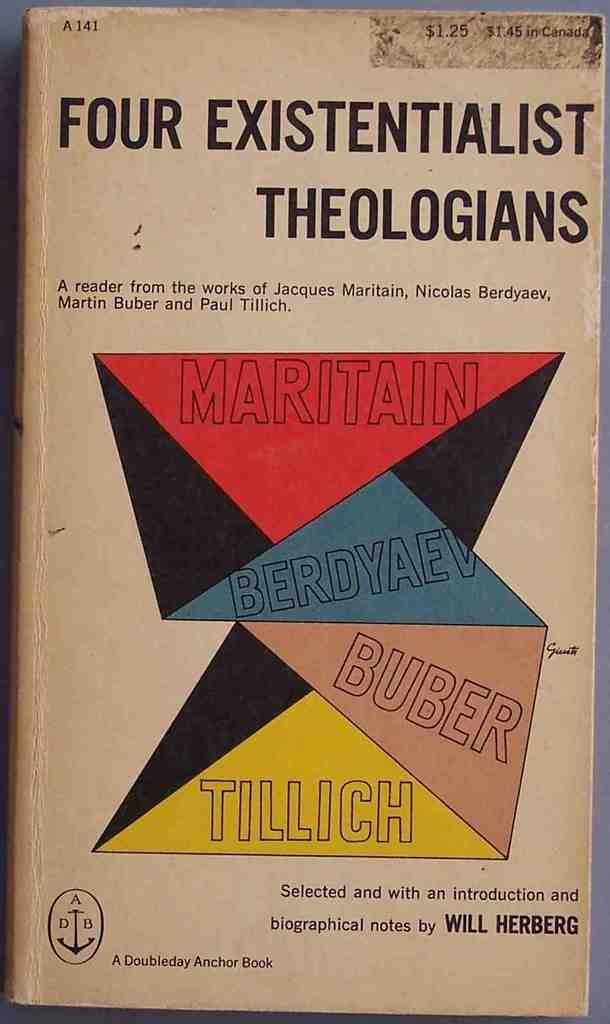<image>
Render a clear and concise summary of the photo. A book featuring the works from four existential theologians. 